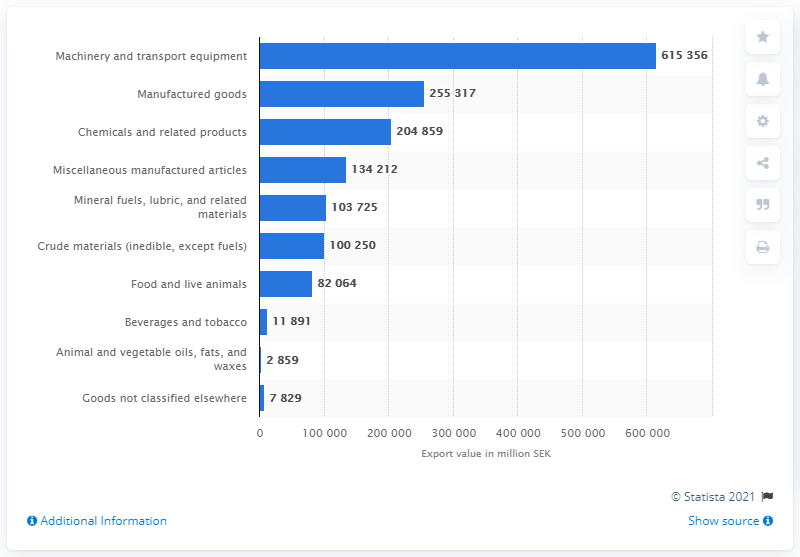Outline some significant characteristics in this image. In 2019, the amount of Swedish exports of manufactured goods was 255,317 units. In 2019, a total of 615,356 Swedish kronor were exported from machinery and transport equipment. 